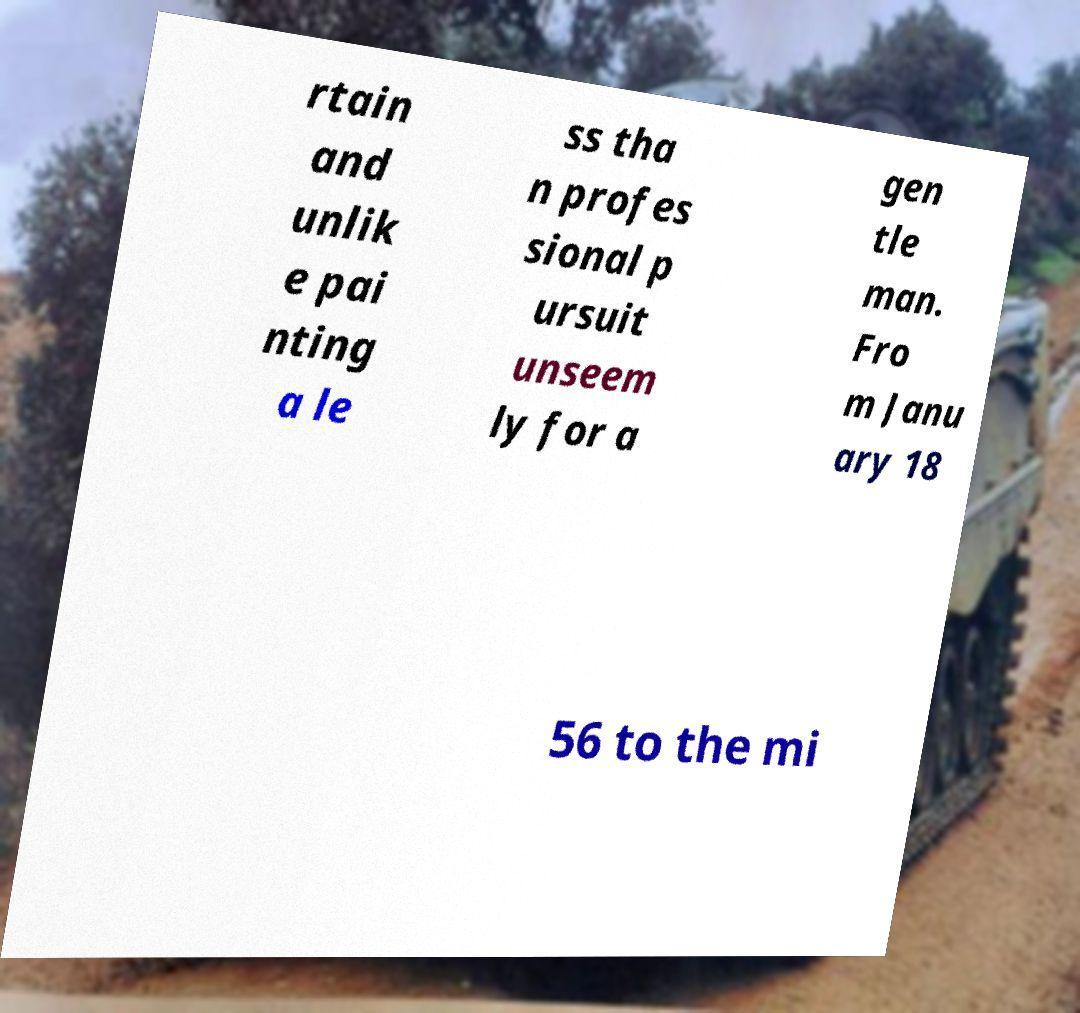What messages or text are displayed in this image? I need them in a readable, typed format. rtain and unlik e pai nting a le ss tha n profes sional p ursuit unseem ly for a gen tle man. Fro m Janu ary 18 56 to the mi 